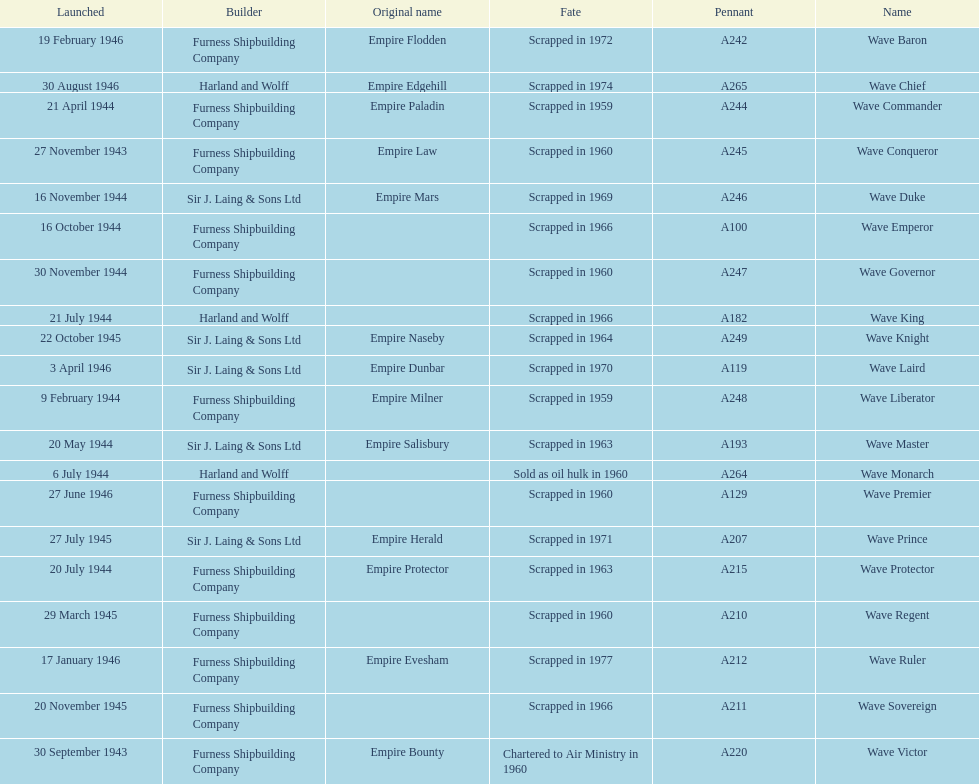What was the next wave class oiler after wave emperor? Wave Duke. 